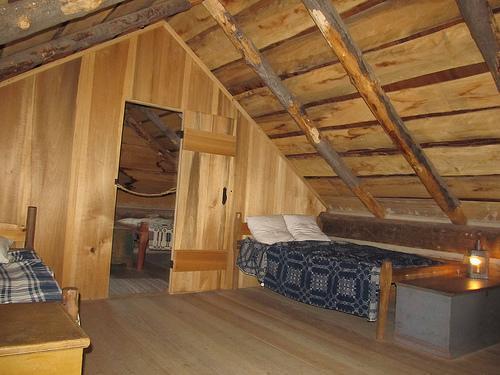How many people are in the picture?
Give a very brief answer. 0. 